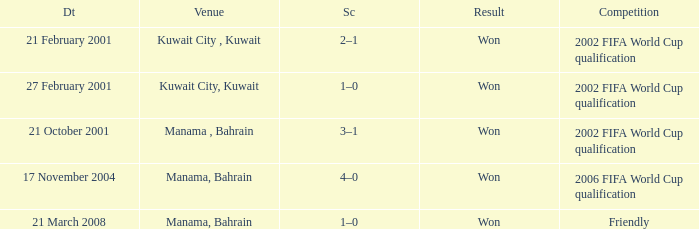On which date was the match in Manama, Bahrain? 21 October 2001, 17 November 2004, 21 March 2008. 